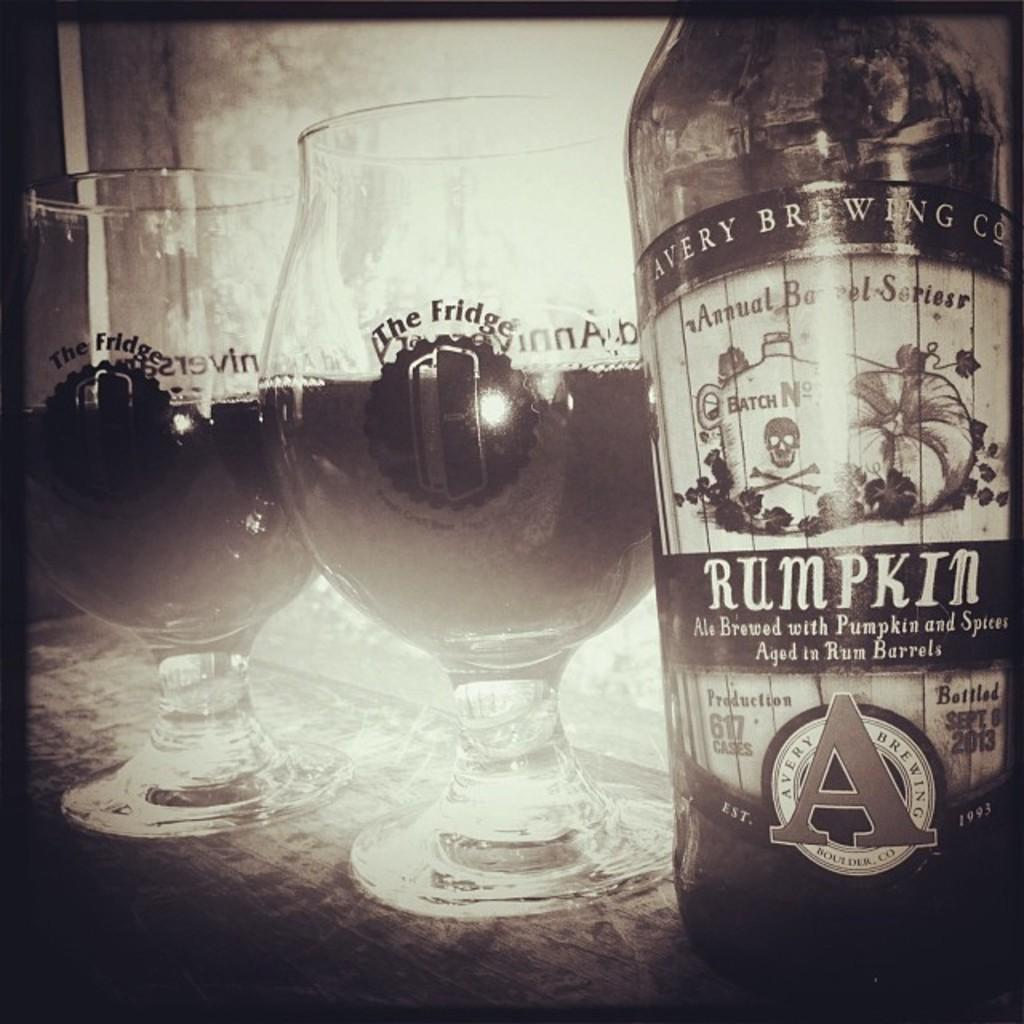What is the color scheme of the image? The image is black and white. What objects can be seen in the image? There are glasses and a bottle in the image. Where are the glasses and bottle located in relation to other elements in the image? The glasses and bottle are in front of a window. Are there any markings or text on the glasses and bottle? Yes, there is writing on the glasses and the bottle. How many trucks are visible in the image? There are no trucks present in the image; it features glasses, a bottle, and a window. What type of milk can be seen in the image? There is no milk visible in the image. 